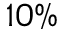<formula> <loc_0><loc_0><loc_500><loc_500>1 0 \%</formula> 